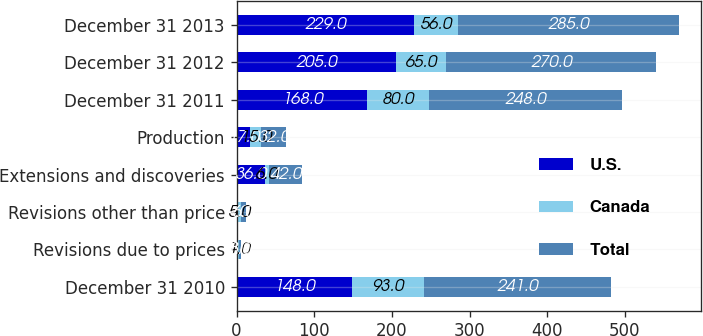Convert chart. <chart><loc_0><loc_0><loc_500><loc_500><stacked_bar_chart><ecel><fcel>December 31 2010<fcel>Revisions due to prices<fcel>Revisions other than price<fcel>Extensions and discoveries<fcel>Production<fcel>December 31 2011<fcel>December 31 2012<fcel>December 31 2013<nl><fcel>U.S.<fcel>148<fcel>2<fcel>1<fcel>36<fcel>17<fcel>168<fcel>205<fcel>229<nl><fcel>Canada<fcel>93<fcel>1<fcel>5<fcel>6<fcel>15<fcel>80<fcel>65<fcel>56<nl><fcel>Total<fcel>241<fcel>3<fcel>6<fcel>42<fcel>32<fcel>248<fcel>270<fcel>285<nl></chart> 